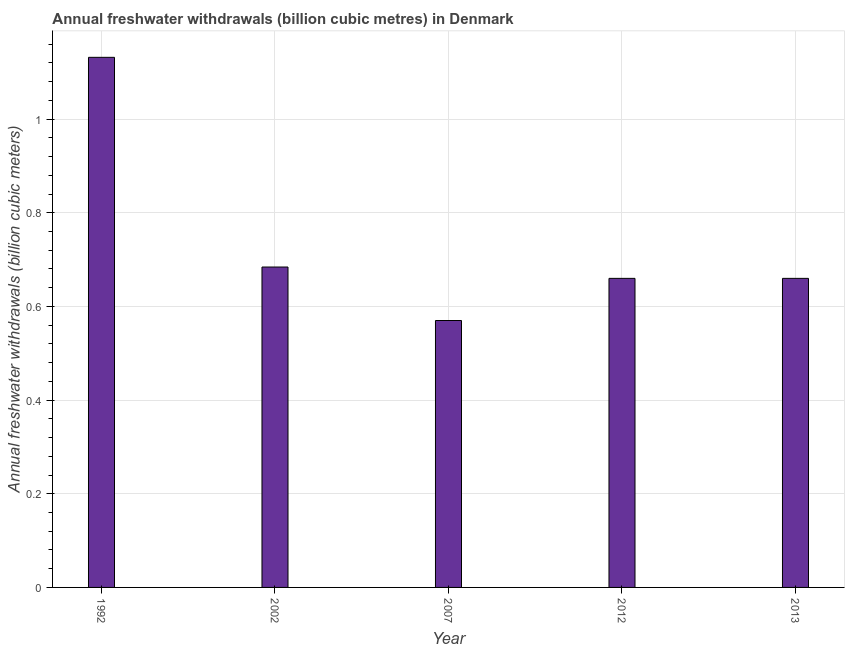What is the title of the graph?
Provide a short and direct response. Annual freshwater withdrawals (billion cubic metres) in Denmark. What is the label or title of the X-axis?
Provide a succinct answer. Year. What is the label or title of the Y-axis?
Provide a succinct answer. Annual freshwater withdrawals (billion cubic meters). What is the annual freshwater withdrawals in 2007?
Offer a very short reply. 0.57. Across all years, what is the maximum annual freshwater withdrawals?
Your answer should be compact. 1.13. Across all years, what is the minimum annual freshwater withdrawals?
Offer a terse response. 0.57. In which year was the annual freshwater withdrawals maximum?
Make the answer very short. 1992. What is the sum of the annual freshwater withdrawals?
Your response must be concise. 3.71. What is the difference between the annual freshwater withdrawals in 2002 and 2007?
Provide a short and direct response. 0.11. What is the average annual freshwater withdrawals per year?
Your answer should be compact. 0.74. What is the median annual freshwater withdrawals?
Offer a terse response. 0.66. Do a majority of the years between 1992 and 2007 (inclusive) have annual freshwater withdrawals greater than 0.6 billion cubic meters?
Offer a very short reply. Yes. What is the ratio of the annual freshwater withdrawals in 2007 to that in 2013?
Keep it short and to the point. 0.86. Is the difference between the annual freshwater withdrawals in 2007 and 2012 greater than the difference between any two years?
Make the answer very short. No. What is the difference between the highest and the second highest annual freshwater withdrawals?
Offer a terse response. 0.45. What is the difference between the highest and the lowest annual freshwater withdrawals?
Keep it short and to the point. 0.56. In how many years, is the annual freshwater withdrawals greater than the average annual freshwater withdrawals taken over all years?
Your answer should be very brief. 1. Are all the bars in the graph horizontal?
Your answer should be very brief. No. What is the difference between two consecutive major ticks on the Y-axis?
Your response must be concise. 0.2. Are the values on the major ticks of Y-axis written in scientific E-notation?
Your response must be concise. No. What is the Annual freshwater withdrawals (billion cubic meters) of 1992?
Give a very brief answer. 1.13. What is the Annual freshwater withdrawals (billion cubic meters) of 2002?
Offer a terse response. 0.68. What is the Annual freshwater withdrawals (billion cubic meters) in 2007?
Provide a short and direct response. 0.57. What is the Annual freshwater withdrawals (billion cubic meters) of 2012?
Ensure brevity in your answer.  0.66. What is the Annual freshwater withdrawals (billion cubic meters) of 2013?
Keep it short and to the point. 0.66. What is the difference between the Annual freshwater withdrawals (billion cubic meters) in 1992 and 2002?
Provide a succinct answer. 0.45. What is the difference between the Annual freshwater withdrawals (billion cubic meters) in 1992 and 2007?
Your response must be concise. 0.56. What is the difference between the Annual freshwater withdrawals (billion cubic meters) in 1992 and 2012?
Ensure brevity in your answer.  0.47. What is the difference between the Annual freshwater withdrawals (billion cubic meters) in 1992 and 2013?
Offer a very short reply. 0.47. What is the difference between the Annual freshwater withdrawals (billion cubic meters) in 2002 and 2007?
Offer a very short reply. 0.11. What is the difference between the Annual freshwater withdrawals (billion cubic meters) in 2002 and 2012?
Your response must be concise. 0.02. What is the difference between the Annual freshwater withdrawals (billion cubic meters) in 2002 and 2013?
Give a very brief answer. 0.02. What is the difference between the Annual freshwater withdrawals (billion cubic meters) in 2007 and 2012?
Offer a terse response. -0.09. What is the difference between the Annual freshwater withdrawals (billion cubic meters) in 2007 and 2013?
Your response must be concise. -0.09. What is the ratio of the Annual freshwater withdrawals (billion cubic meters) in 1992 to that in 2002?
Your answer should be very brief. 1.65. What is the ratio of the Annual freshwater withdrawals (billion cubic meters) in 1992 to that in 2007?
Your answer should be compact. 1.99. What is the ratio of the Annual freshwater withdrawals (billion cubic meters) in 1992 to that in 2012?
Your answer should be very brief. 1.72. What is the ratio of the Annual freshwater withdrawals (billion cubic meters) in 1992 to that in 2013?
Provide a short and direct response. 1.72. What is the ratio of the Annual freshwater withdrawals (billion cubic meters) in 2002 to that in 2013?
Provide a short and direct response. 1.04. What is the ratio of the Annual freshwater withdrawals (billion cubic meters) in 2007 to that in 2012?
Give a very brief answer. 0.86. What is the ratio of the Annual freshwater withdrawals (billion cubic meters) in 2007 to that in 2013?
Offer a very short reply. 0.86. What is the ratio of the Annual freshwater withdrawals (billion cubic meters) in 2012 to that in 2013?
Ensure brevity in your answer.  1. 